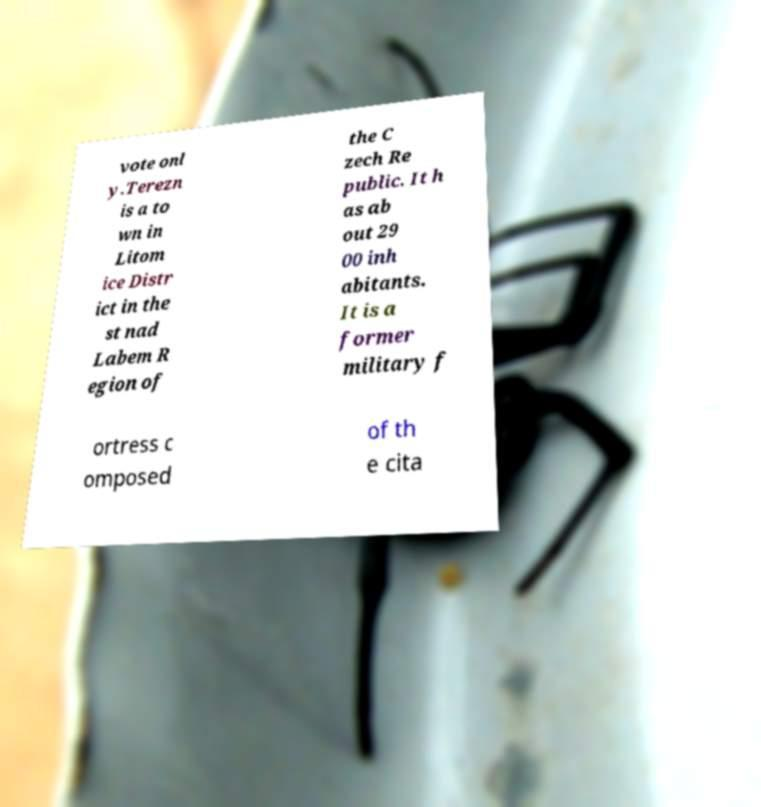What messages or text are displayed in this image? I need them in a readable, typed format. vote onl y.Terezn is a to wn in Litom ice Distr ict in the st nad Labem R egion of the C zech Re public. It h as ab out 29 00 inh abitants. It is a former military f ortress c omposed of th e cita 